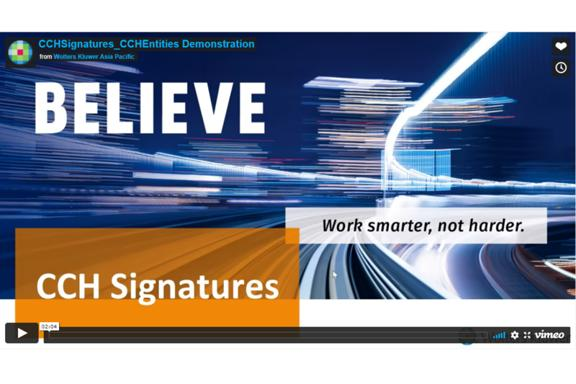What is the message on the screen? The message displayed on the screen is: 'BELIEVE Work smarter, not harder.' This phrase encourages efficiency and clever problem-solving over merely investing more time and effort. 